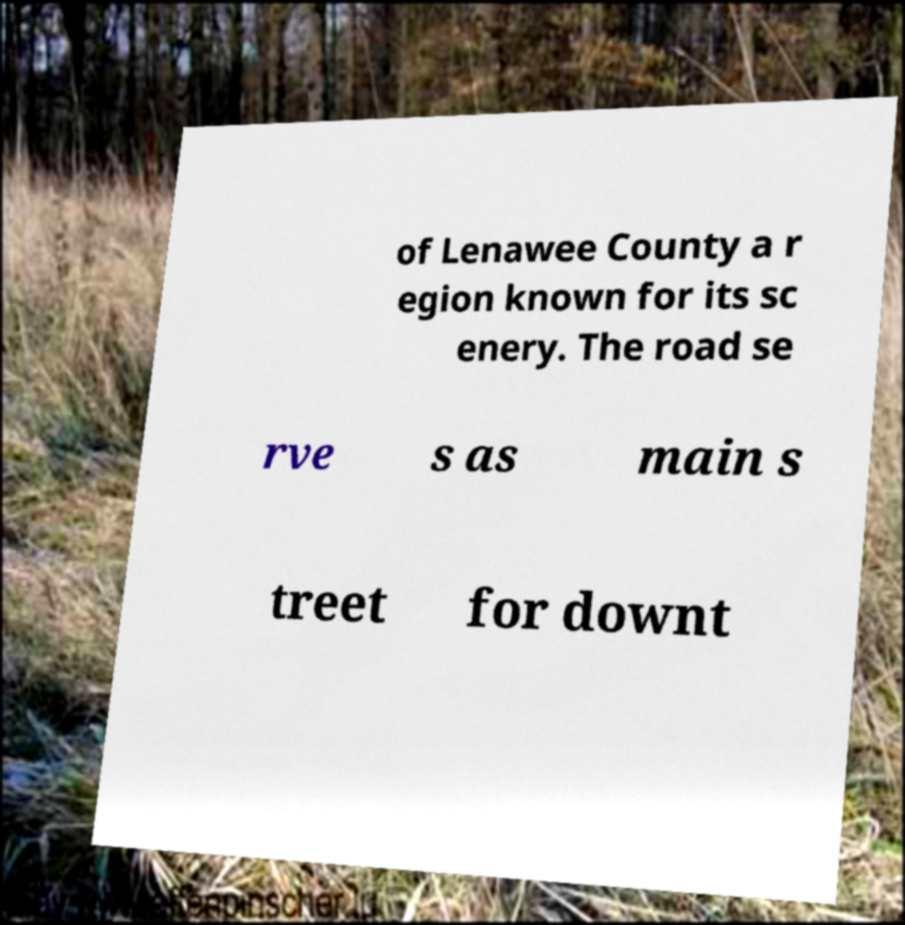Could you extract and type out the text from this image? of Lenawee County a r egion known for its sc enery. The road se rve s as main s treet for downt 